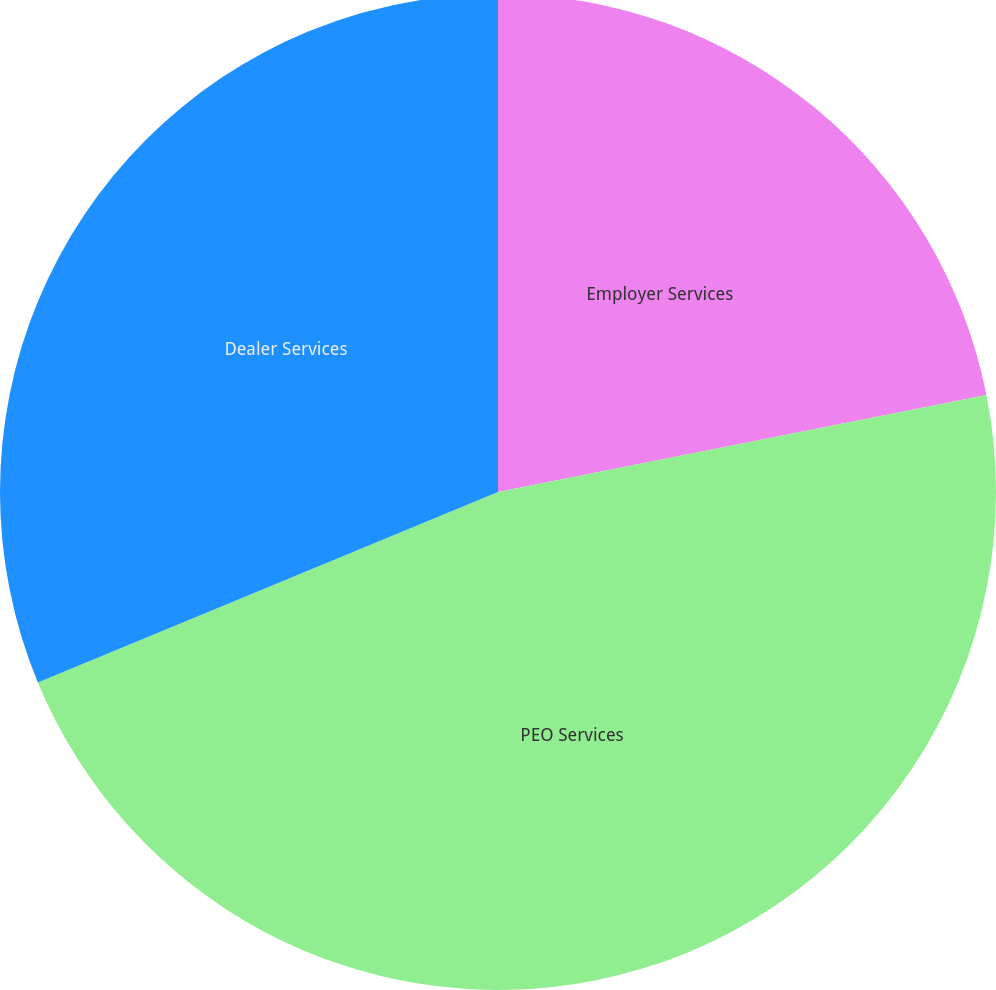Convert chart. <chart><loc_0><loc_0><loc_500><loc_500><pie_chart><fcel>Employer Services<fcel>PEO Services<fcel>Dealer Services<nl><fcel>21.88%<fcel>46.88%<fcel>31.25%<nl></chart> 